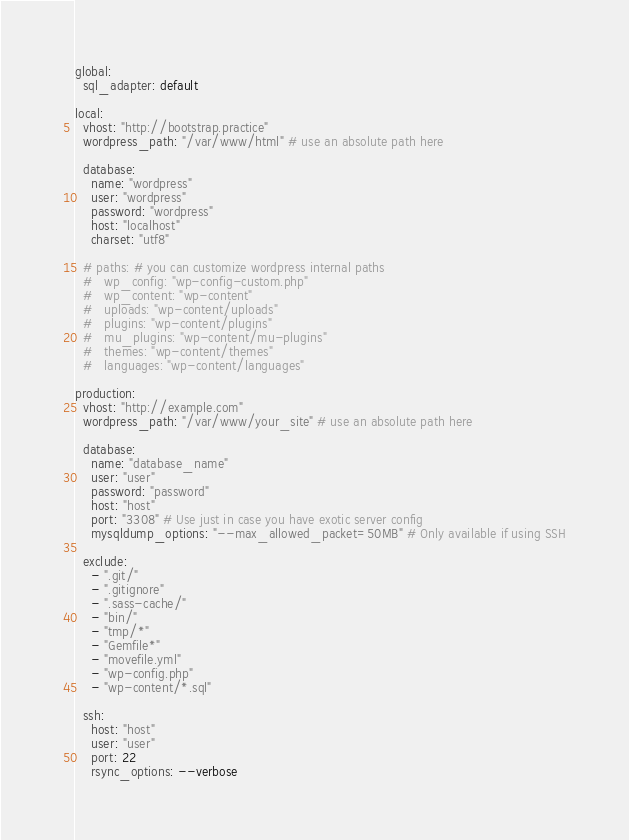Convert code to text. <code><loc_0><loc_0><loc_500><loc_500><_YAML_>global:
  sql_adapter: default

local:
  vhost: "http://bootstrap.practice"
  wordpress_path: "/var/www/html" # use an absolute path here

  database:
    name: "wordpress"
    user: "wordpress"
    password: "wordpress"
    host: "localhost"
    charset: "utf8"

  # paths: # you can customize wordpress internal paths
  #   wp_config: "wp-config-custom.php"
  #   wp_content: "wp-content"
  #   uploads: "wp-content/uploads"
  #   plugins: "wp-content/plugins"
  #   mu_plugins: "wp-content/mu-plugins"
  #   themes: "wp-content/themes"
  #   languages: "wp-content/languages"

production:
  vhost: "http://example.com"
  wordpress_path: "/var/www/your_site" # use an absolute path here

  database:
    name: "database_name"
    user: "user"
    password: "password"
    host: "host"
    port: "3308" # Use just in case you have exotic server config
    mysqldump_options: "--max_allowed_packet=50MB" # Only available if using SSH

  exclude:
    - ".git/"
    - ".gitignore"
    - ".sass-cache/"
    - "bin/"
    - "tmp/*"
    - "Gemfile*"
    - "movefile.yml"
    - "wp-config.php"
    - "wp-content/*.sql"

  ssh:
    host: "host"
    user: "user"
    port: 22
    rsync_options: --verbose
</code> 